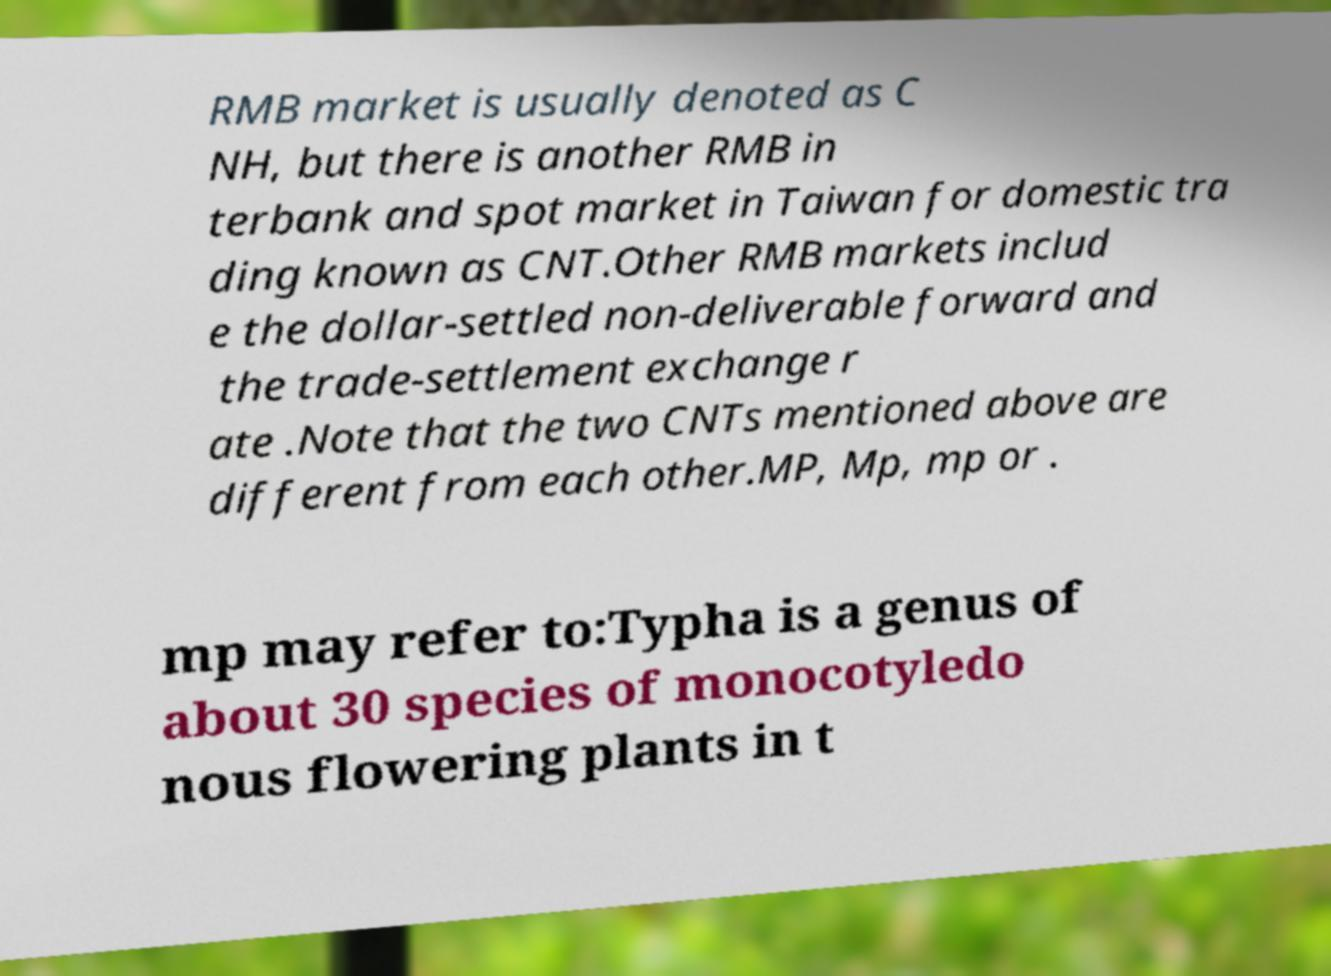I need the written content from this picture converted into text. Can you do that? RMB market is usually denoted as C NH, but there is another RMB in terbank and spot market in Taiwan for domestic tra ding known as CNT.Other RMB markets includ e the dollar-settled non-deliverable forward and the trade-settlement exchange r ate .Note that the two CNTs mentioned above are different from each other.MP, Mp, mp or . mp may refer to:Typha is a genus of about 30 species of monocotyledo nous flowering plants in t 